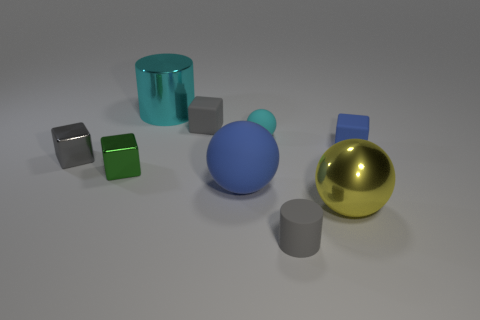What number of rubber objects are either spheres or large blue spheres?
Offer a terse response. 2. Is there a sphere that is behind the blue rubber ball that is right of the tiny gray shiny object?
Make the answer very short. Yes. Do the cyan object that is left of the small ball and the small gray cylinder have the same material?
Your response must be concise. No. How many other objects are there of the same color as the metallic ball?
Provide a short and direct response. 0. Is the color of the large metal ball the same as the large rubber thing?
Provide a short and direct response. No. What size is the blue rubber object that is to the right of the blue thing in front of the tiny gray metal object?
Your answer should be very brief. Small. Is the material of the cylinder that is in front of the big cyan cylinder the same as the large ball that is in front of the large blue matte thing?
Provide a short and direct response. No. Is the color of the tiny matte thing that is right of the big metallic ball the same as the small matte sphere?
Your answer should be very brief. No. There is a yellow metal thing; what number of tiny objects are behind it?
Give a very brief answer. 5. Are the large blue sphere and the large ball that is on the right side of the big blue matte ball made of the same material?
Your answer should be compact. No. 